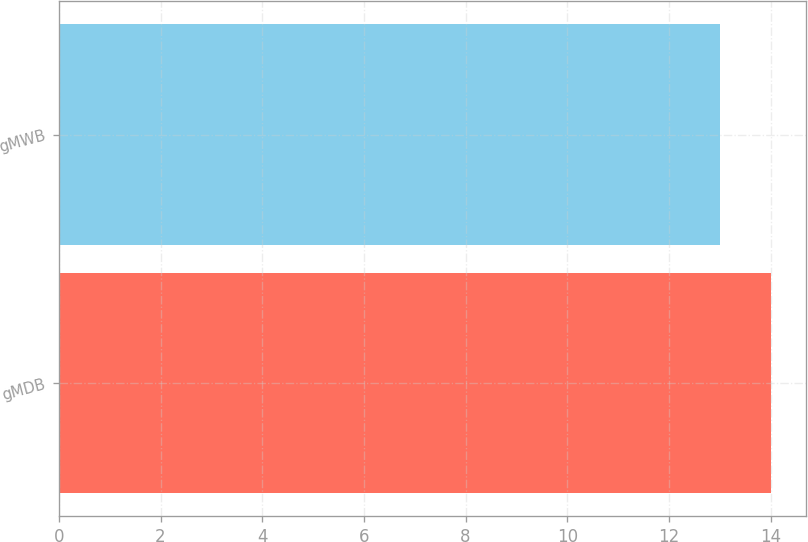<chart> <loc_0><loc_0><loc_500><loc_500><bar_chart><fcel>gMDB<fcel>gMWB<nl><fcel>14<fcel>13<nl></chart> 